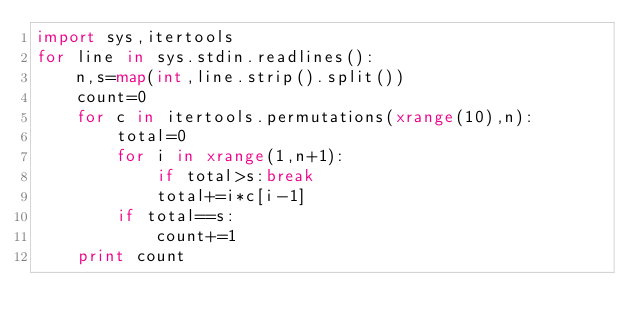<code> <loc_0><loc_0><loc_500><loc_500><_Python_>import sys,itertools
for line in sys.stdin.readlines():
    n,s=map(int,line.strip().split())
    count=0
    for c in itertools.permutations(xrange(10),n):
        total=0
        for i in xrange(1,n+1):
            if total>s:break
            total+=i*c[i-1]
        if total==s:
            count+=1
    print count</code> 